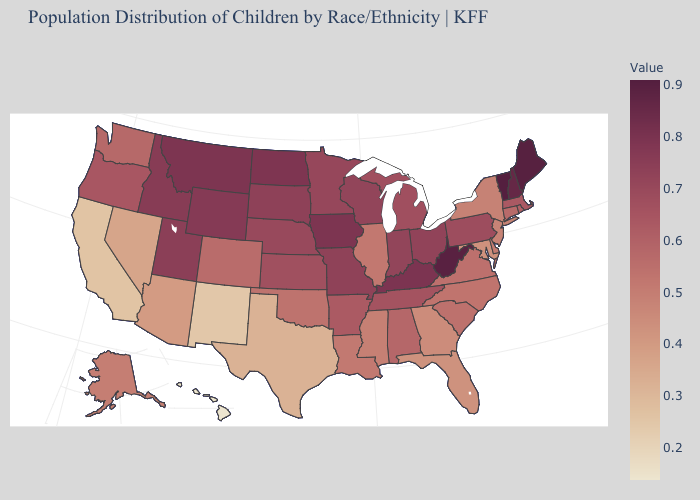Does Vermont have the highest value in the USA?
Answer briefly. Yes. Is the legend a continuous bar?
Short answer required. Yes. Does West Virginia have a higher value than Maryland?
Write a very short answer. Yes. Is the legend a continuous bar?
Give a very brief answer. Yes. 